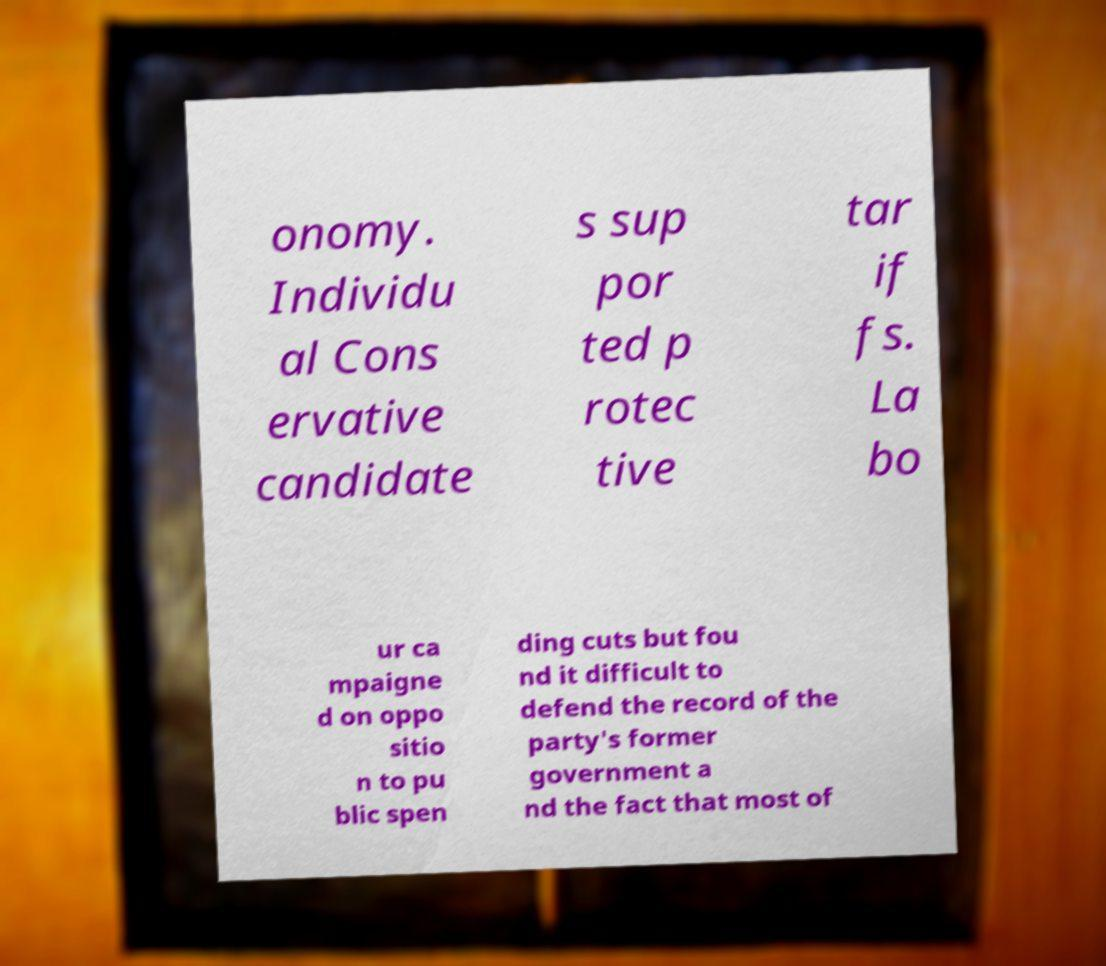Could you extract and type out the text from this image? onomy. Individu al Cons ervative candidate s sup por ted p rotec tive tar if fs. La bo ur ca mpaigne d on oppo sitio n to pu blic spen ding cuts but fou nd it difficult to defend the record of the party's former government a nd the fact that most of 